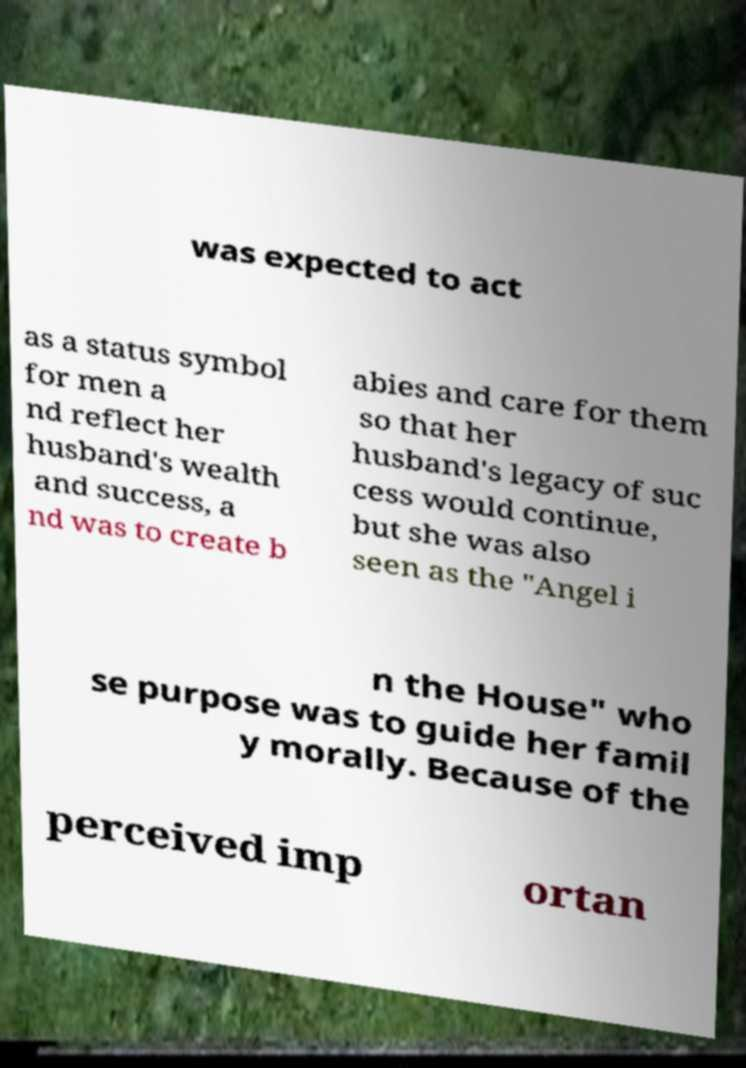For documentation purposes, I need the text within this image transcribed. Could you provide that? was expected to act as a status symbol for men a nd reflect her husband's wealth and success, a nd was to create b abies and care for them so that her husband's legacy of suc cess would continue, but she was also seen as the "Angel i n the House" who se purpose was to guide her famil y morally. Because of the perceived imp ortan 